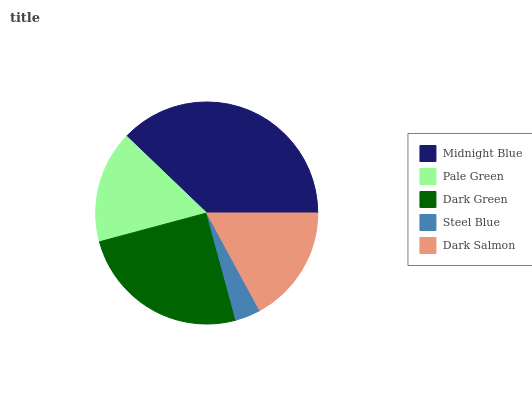Is Steel Blue the minimum?
Answer yes or no. Yes. Is Midnight Blue the maximum?
Answer yes or no. Yes. Is Pale Green the minimum?
Answer yes or no. No. Is Pale Green the maximum?
Answer yes or no. No. Is Midnight Blue greater than Pale Green?
Answer yes or no. Yes. Is Pale Green less than Midnight Blue?
Answer yes or no. Yes. Is Pale Green greater than Midnight Blue?
Answer yes or no. No. Is Midnight Blue less than Pale Green?
Answer yes or no. No. Is Dark Salmon the high median?
Answer yes or no. Yes. Is Dark Salmon the low median?
Answer yes or no. Yes. Is Midnight Blue the high median?
Answer yes or no. No. Is Steel Blue the low median?
Answer yes or no. No. 